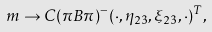Convert formula to latex. <formula><loc_0><loc_0><loc_500><loc_500>m \rightarrow C ( \pi B \pi ) ^ { - } ( \cdot , \eta _ { 2 3 } , \xi _ { 2 3 } , \cdot ) ^ { T } ,</formula> 